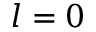Convert formula to latex. <formula><loc_0><loc_0><loc_500><loc_500>l = 0</formula> 